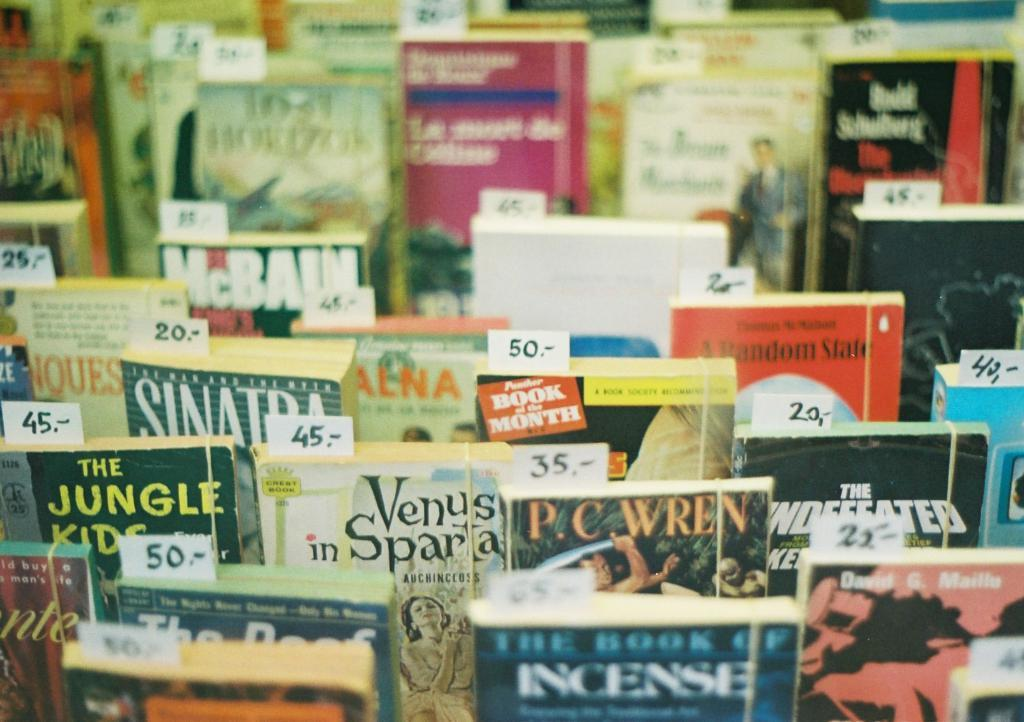<image>
Offer a succinct explanation of the picture presented. the word sinatra is on the book among the group 